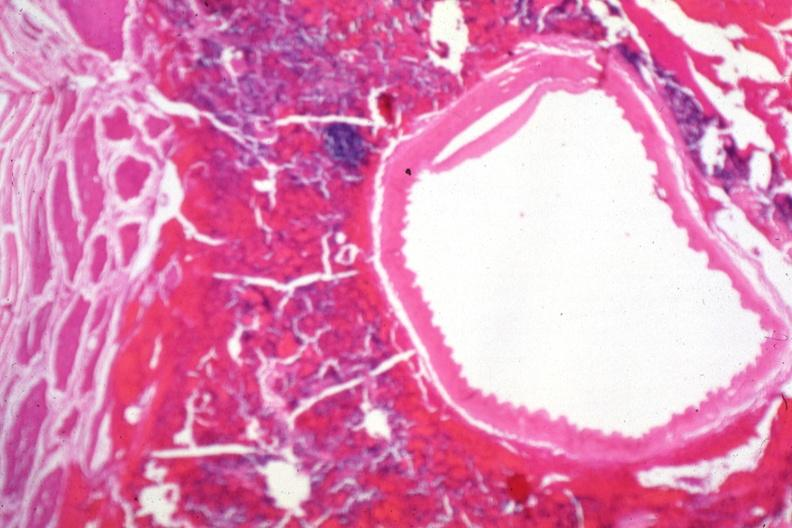s nodule present?
Answer the question using a single word or phrase. No 